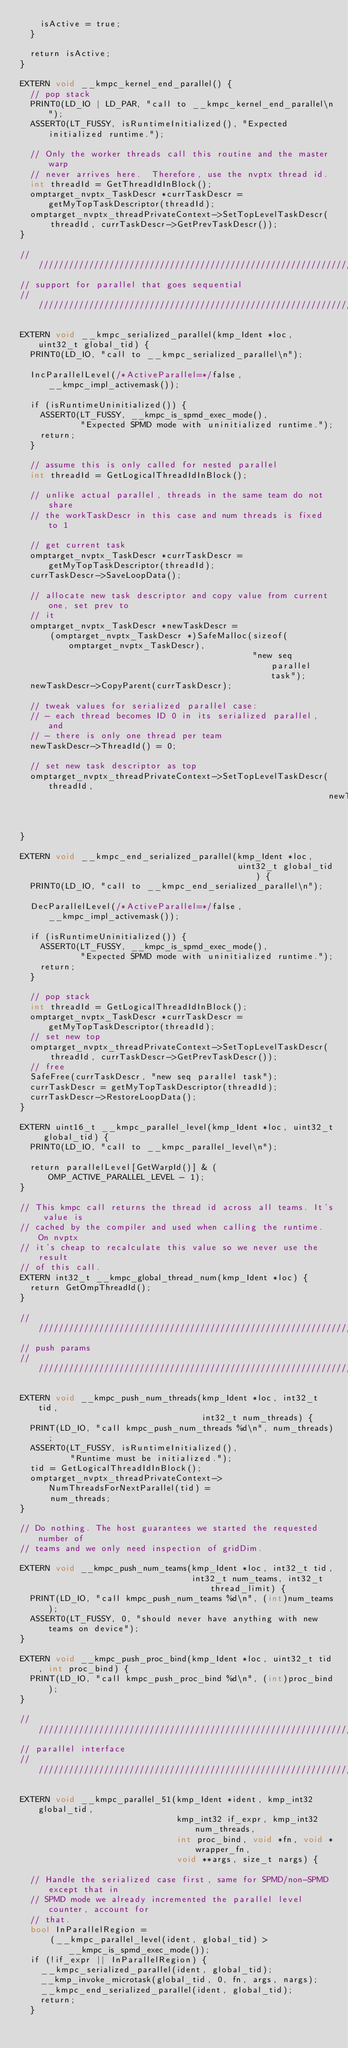Convert code to text. <code><loc_0><loc_0><loc_500><loc_500><_Cuda_>    isActive = true;
  }

  return isActive;
}

EXTERN void __kmpc_kernel_end_parallel() {
  // pop stack
  PRINT0(LD_IO | LD_PAR, "call to __kmpc_kernel_end_parallel\n");
  ASSERT0(LT_FUSSY, isRuntimeInitialized(), "Expected initialized runtime.");

  // Only the worker threads call this routine and the master warp
  // never arrives here.  Therefore, use the nvptx thread id.
  int threadId = GetThreadIdInBlock();
  omptarget_nvptx_TaskDescr *currTaskDescr = getMyTopTaskDescriptor(threadId);
  omptarget_nvptx_threadPrivateContext->SetTopLevelTaskDescr(
      threadId, currTaskDescr->GetPrevTaskDescr());
}

////////////////////////////////////////////////////////////////////////////////
// support for parallel that goes sequential
////////////////////////////////////////////////////////////////////////////////

EXTERN void __kmpc_serialized_parallel(kmp_Ident *loc, uint32_t global_tid) {
  PRINT0(LD_IO, "call to __kmpc_serialized_parallel\n");

  IncParallelLevel(/*ActiveParallel=*/false, __kmpc_impl_activemask());

  if (isRuntimeUninitialized()) {
    ASSERT0(LT_FUSSY, __kmpc_is_spmd_exec_mode(),
            "Expected SPMD mode with uninitialized runtime.");
    return;
  }

  // assume this is only called for nested parallel
  int threadId = GetLogicalThreadIdInBlock();

  // unlike actual parallel, threads in the same team do not share
  // the workTaskDescr in this case and num threads is fixed to 1

  // get current task
  omptarget_nvptx_TaskDescr *currTaskDescr = getMyTopTaskDescriptor(threadId);
  currTaskDescr->SaveLoopData();

  // allocate new task descriptor and copy value from current one, set prev to
  // it
  omptarget_nvptx_TaskDescr *newTaskDescr =
      (omptarget_nvptx_TaskDescr *)SafeMalloc(sizeof(omptarget_nvptx_TaskDescr),
                                              "new seq parallel task");
  newTaskDescr->CopyParent(currTaskDescr);

  // tweak values for serialized parallel case:
  // - each thread becomes ID 0 in its serialized parallel, and
  // - there is only one thread per team
  newTaskDescr->ThreadId() = 0;

  // set new task descriptor as top
  omptarget_nvptx_threadPrivateContext->SetTopLevelTaskDescr(threadId,
                                                             newTaskDescr);
}

EXTERN void __kmpc_end_serialized_parallel(kmp_Ident *loc,
                                           uint32_t global_tid) {
  PRINT0(LD_IO, "call to __kmpc_end_serialized_parallel\n");

  DecParallelLevel(/*ActiveParallel=*/false, __kmpc_impl_activemask());

  if (isRuntimeUninitialized()) {
    ASSERT0(LT_FUSSY, __kmpc_is_spmd_exec_mode(),
            "Expected SPMD mode with uninitialized runtime.");
    return;
  }

  // pop stack
  int threadId = GetLogicalThreadIdInBlock();
  omptarget_nvptx_TaskDescr *currTaskDescr = getMyTopTaskDescriptor(threadId);
  // set new top
  omptarget_nvptx_threadPrivateContext->SetTopLevelTaskDescr(
      threadId, currTaskDescr->GetPrevTaskDescr());
  // free
  SafeFree(currTaskDescr, "new seq parallel task");
  currTaskDescr = getMyTopTaskDescriptor(threadId);
  currTaskDescr->RestoreLoopData();
}

EXTERN uint16_t __kmpc_parallel_level(kmp_Ident *loc, uint32_t global_tid) {
  PRINT0(LD_IO, "call to __kmpc_parallel_level\n");

  return parallelLevel[GetWarpId()] & (OMP_ACTIVE_PARALLEL_LEVEL - 1);
}

// This kmpc call returns the thread id across all teams. It's value is
// cached by the compiler and used when calling the runtime. On nvptx
// it's cheap to recalculate this value so we never use the result
// of this call.
EXTERN int32_t __kmpc_global_thread_num(kmp_Ident *loc) {
  return GetOmpThreadId();
}

////////////////////////////////////////////////////////////////////////////////
// push params
////////////////////////////////////////////////////////////////////////////////

EXTERN void __kmpc_push_num_threads(kmp_Ident *loc, int32_t tid,
                                    int32_t num_threads) {
  PRINT(LD_IO, "call kmpc_push_num_threads %d\n", num_threads);
  ASSERT0(LT_FUSSY, isRuntimeInitialized(),
          "Runtime must be initialized.");
  tid = GetLogicalThreadIdInBlock();
  omptarget_nvptx_threadPrivateContext->NumThreadsForNextParallel(tid) =
      num_threads;
}

// Do nothing. The host guarantees we started the requested number of
// teams and we only need inspection of gridDim.

EXTERN void __kmpc_push_num_teams(kmp_Ident *loc, int32_t tid,
                                  int32_t num_teams, int32_t thread_limit) {
  PRINT(LD_IO, "call kmpc_push_num_teams %d\n", (int)num_teams);
  ASSERT0(LT_FUSSY, 0, "should never have anything with new teams on device");
}

EXTERN void __kmpc_push_proc_bind(kmp_Ident *loc, uint32_t tid, int proc_bind) {
  PRINT(LD_IO, "call kmpc_push_proc_bind %d\n", (int)proc_bind);
}

////////////////////////////////////////////////////////////////////////////////
// parallel interface
////////////////////////////////////////////////////////////////////////////////

EXTERN void __kmpc_parallel_51(kmp_Ident *ident, kmp_int32 global_tid,
                               kmp_int32 if_expr, kmp_int32 num_threads,
                               int proc_bind, void *fn, void *wrapper_fn,
                               void **args, size_t nargs) {

  // Handle the serialized case first, same for SPMD/non-SPMD except that in
  // SPMD mode we already incremented the parallel level counter, account for
  // that.
  bool InParallelRegion =
      (__kmpc_parallel_level(ident, global_tid) > __kmpc_is_spmd_exec_mode());
  if (!if_expr || InParallelRegion) {
    __kmpc_serialized_parallel(ident, global_tid);
    __kmp_invoke_microtask(global_tid, 0, fn, args, nargs);
    __kmpc_end_serialized_parallel(ident, global_tid);
    return;
  }
</code> 